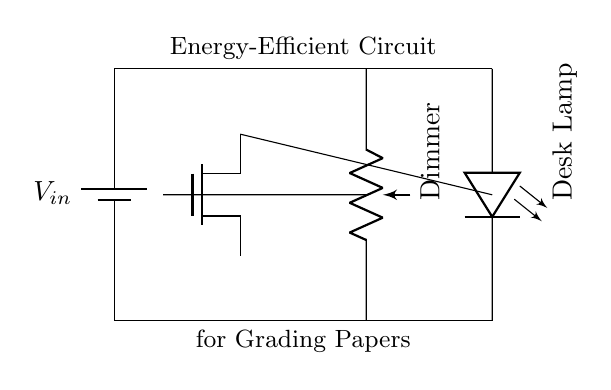What is the main component used to dim the lamp? The dimmer in this circuit is a potentiometer, which varies the resistance and controls the brightness of the desk lamp.
Answer: potentiometer What type of transistor is used in this circuit? The circuit employs an NMOS transistor, which is indicated by its label, and is used to control the current to the lamp based on the potentiometer's setting.
Answer: NMOS How many primary components are there in the circuit? There are four primary components: a battery, an NMOS transistor, a potentiometer, and an LED desk lamp.
Answer: four What is the purpose of the NMOS transistor in this circuit? The NMOS transistor acts as a switch to regulate the current flowing to the desk lamp based on the resistance set by the potentiometer.
Answer: switch Which component is responsible for providing light? The LED is responsible for providing light, as it is the device designed to emit illumination when current passes through it.
Answer: LED What does the circuit illustrate in terms of energy consumption? The circuit illustrates an energy-efficient focus, as it utilizes a dimmer to minimize power consumption while providing adequate light for grading papers.
Answer: energy-efficient At which point of the circuit is the input voltage applied? The input voltage is applied across the battery, which serves as the power source connected to the NMOS transistor.
Answer: battery 